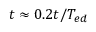Convert formula to latex. <formula><loc_0><loc_0><loc_500><loc_500>t \approx 0 . 2 t / T _ { e d }</formula> 